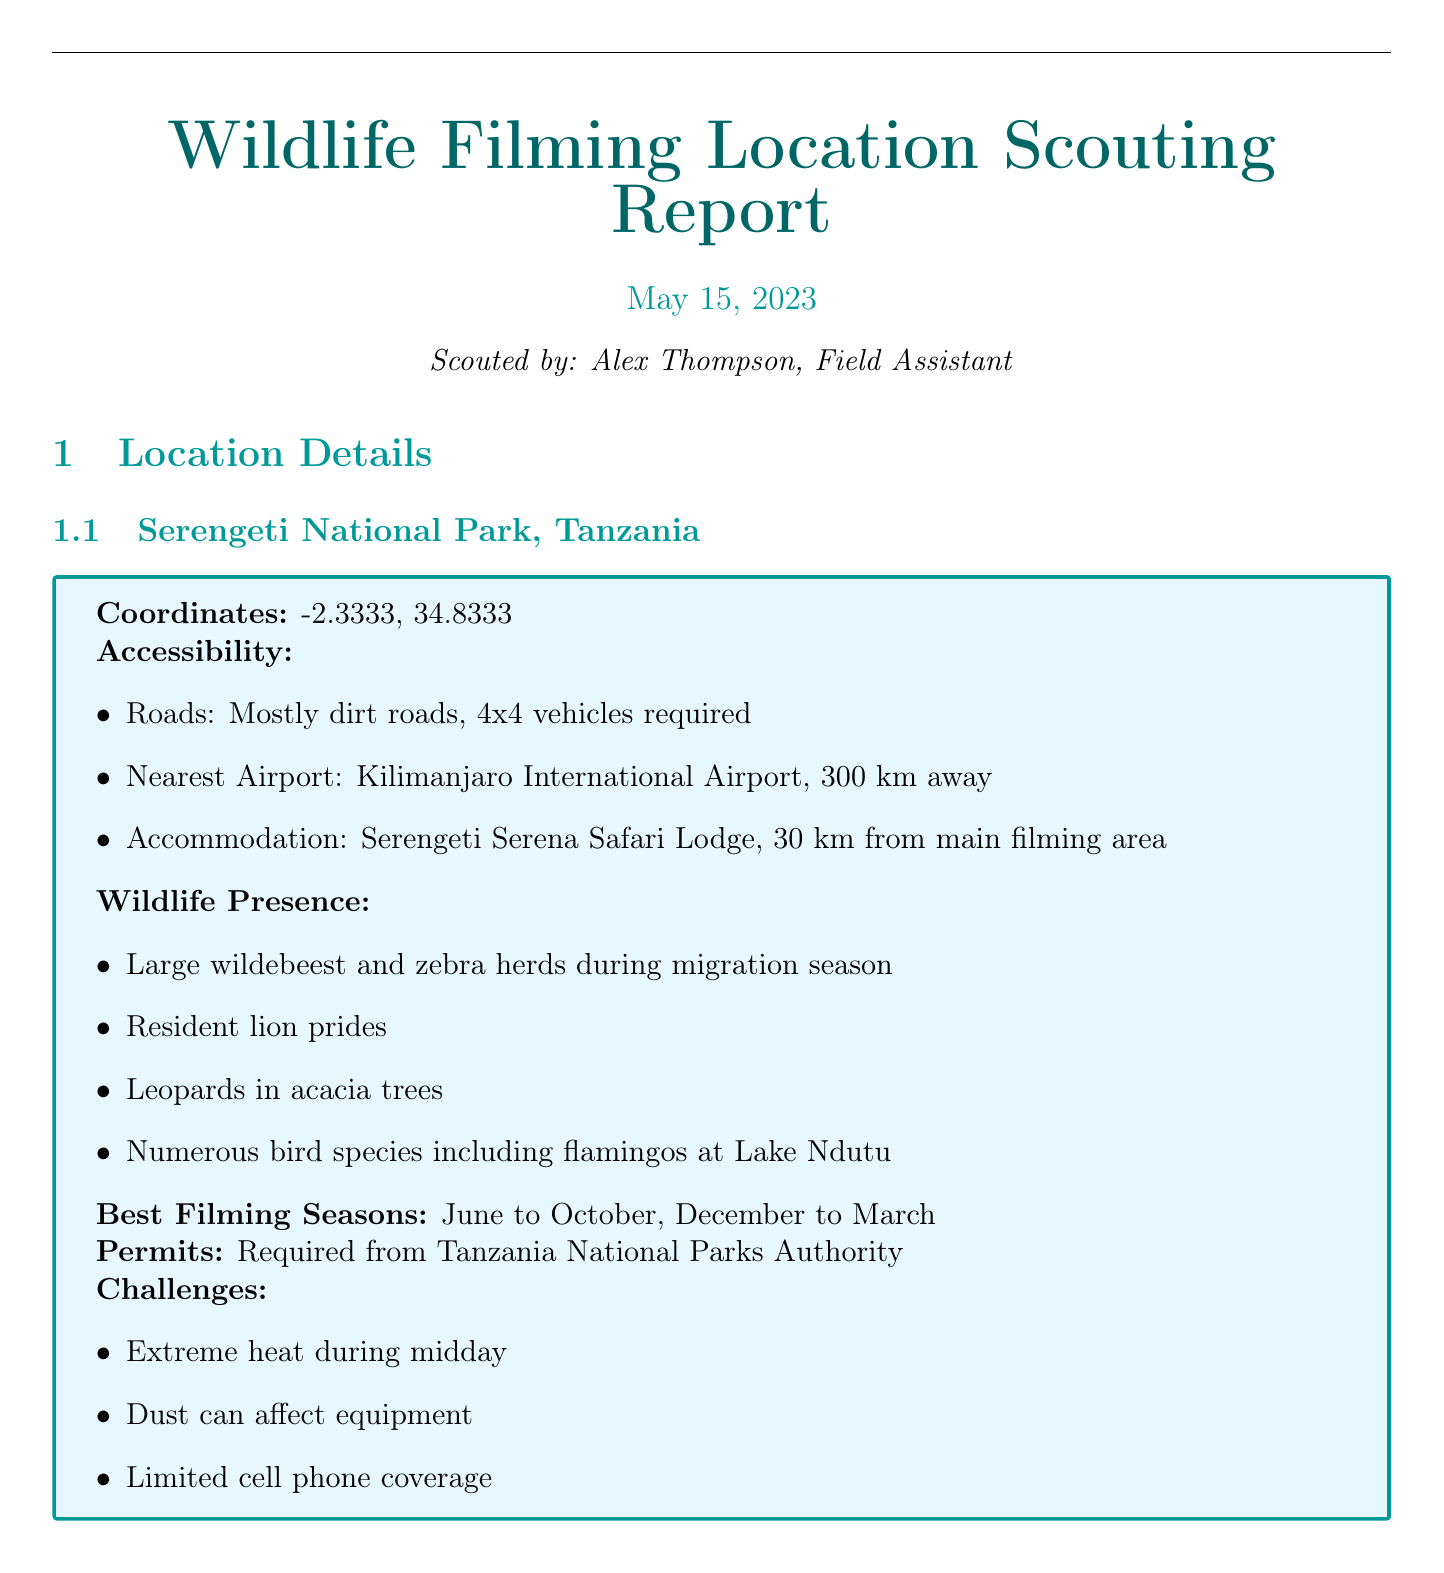What is the scouting date? The scouting date is mentioned in the document as the date when the scouting was conducted.
Answer: 2023-05-15 What wildlife is present in the Daintree Rainforest? The document lists specific wildlife found in the Daintree Rainforest.
Answer: Cassowaries, Tree kangaroos, Saltwater crocodiles, Various frog and reptile species, Spectacled flying foxes What are the best filming seasons for Banff National Park? The best filming seasons are provided for Banff National Park, indicating the preferred times for filming based on conditions.
Answer: May to September, Winter for snow scenes How far is the nearest airport from Serengeti National Park? The distance to the nearest airport is specified for Serengeti National Park, which impacts accessibility.
Answer: 300 km What challenges are mentioned for filming in Serengeti National Park? The document outlines specific challenges that filmmakers may face in Serengeti National Park.
Answer: Extreme heat during midday, Dust can affect equipment, Limited cell phone coverage Which type of permits are required for shooting in Daintree Rainforest? The document specifies the type of permit necessary for filming in Daintree Rainforest.
Answer: Commercial filming permit from Queensland Parks and Wildlife Service What accommodations are available near Banff National Park? The document lists specific accommodations available for filmmakers near Banff National Park.
Answer: Fairmont Banff Springs Hotel in Banff town What equipment consideration is mentioned for remote locations? The document discusses specific equipment needs that filmmakers should consider for remote locations.
Answer: Portable power stations for remote locations 